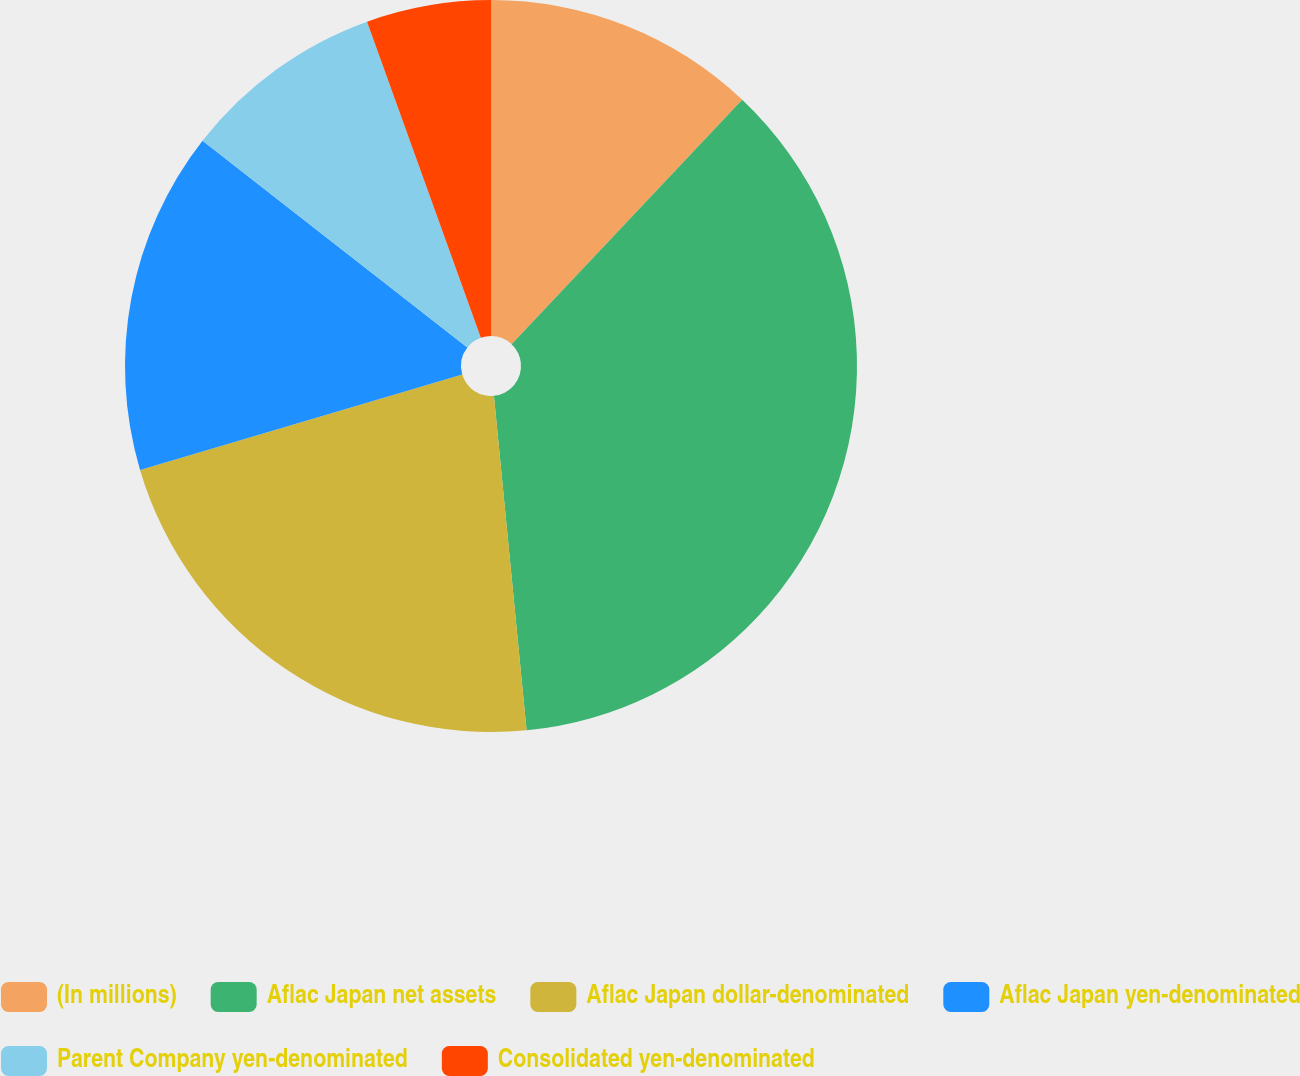<chart> <loc_0><loc_0><loc_500><loc_500><pie_chart><fcel>(In millions)<fcel>Aflac Japan net assets<fcel>Aflac Japan dollar-denominated<fcel>Aflac Japan yen-denominated<fcel>Parent Company yen-denominated<fcel>Consolidated yen-denominated<nl><fcel>12.04%<fcel>36.41%<fcel>21.97%<fcel>15.13%<fcel>8.95%<fcel>5.5%<nl></chart> 